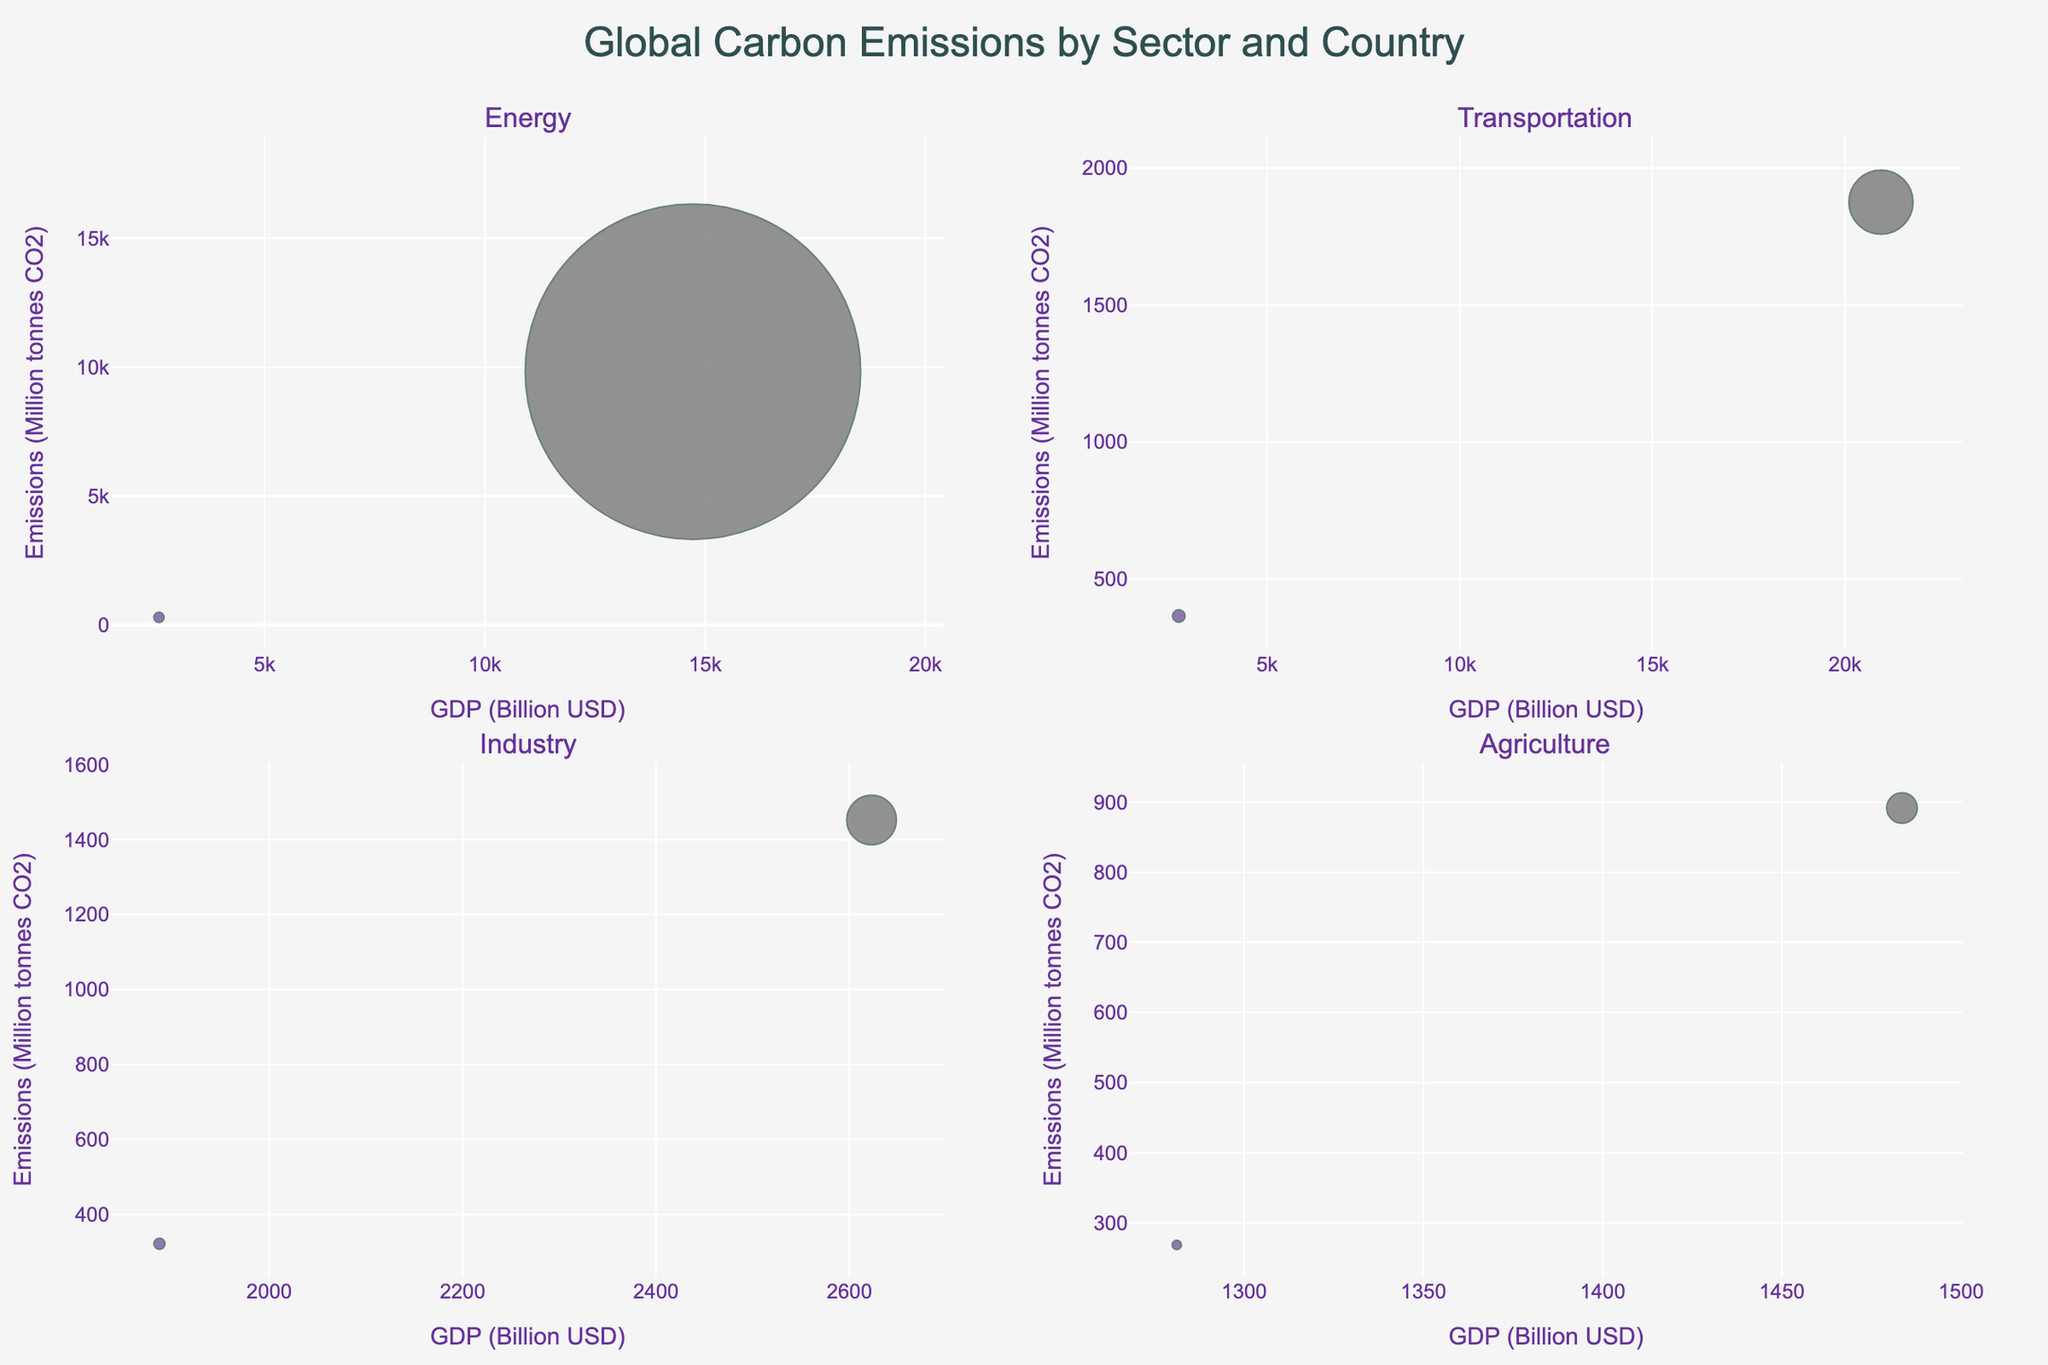what is the title of the figure? The title is positioned at the top center of the figure. It reads "Global Carbon Emissions by Sector and Country".
Answer: Global Carbon Emissions by Sector and Country how many sectors are represented in the figure? The subplot titles indicate four sectors: Energy, Transportation, Industry, and Agriculture.
Answer: 4 what is the x-axis label for the "Transportation" subplot? The x-axis label for each subplot is indicated at the bottom of the x-axis. For the "Transportation" subplot, it is "GDP (Billion USD)".
Answer: GDP (Billion USD) which country has the highest carbon emissions in the "Energy" sector? By looking at the bubbles in the "Energy" sector subplot, it is evident that China has the highest carbon emissions, as indicated by the largest bubble.
Answer: China what is the total emissions for the countries in the "Industry" sector? The emissions for countries in the "Industry" sector are summed up: India (1452.3) + Italy (321.5) = 1773.8 Million tonnes CO2.
Answer: 1773.8 compare the emissions between Germany (Residential) and Canada (Commercial) sectors. Which one is higher and by how much? Germany’s emissions in the "Residential" sector is 718.8, and Canada’s emissions in the "Commercial" sector is 577.4. Subtract the smaller value from the larger one: 718.8 - 577.4 = 141.4. So, Germany’s emissions are higher by 141.4.
Answer: Germany, 141.4 what is the relationship between GDP and emissions in the "Agriculture" sector? By observing the "Agriculture" subplot, there is a positive relationship where countries with higher GDP tend to have higher emissions, as represented by the bubble sizes growing larger with increasing GDP.
Answer: Positive relationship identify the country with the smallest GDP in the "Waste" sector. By comparing the bubbles in the "Waste" sector subplot and referencing their x-positions (GDP), Mexico has the smallest GDP with 1076.16 Billion USD.
Answer: Mexico which sector has the most diverse range of bubble sizes and what does that imply? The "Energy" sector has a wide range of bubble sizes compared to other sectors, implying significant variability in carbon emissions among the countries in this sector.
Answer: Energy how does Brazil’s emissions in the "Manufacturing" sector compare to South Korea’s emissions in the "Construction" sector? Brazil’s emissions in the "Manufacturing" sector is 441.9, and South Korea’s emissions in the "Construction" sector is 611.3. South Korea’s emissions are higher.
Answer: South Korea’s emissions are higher 